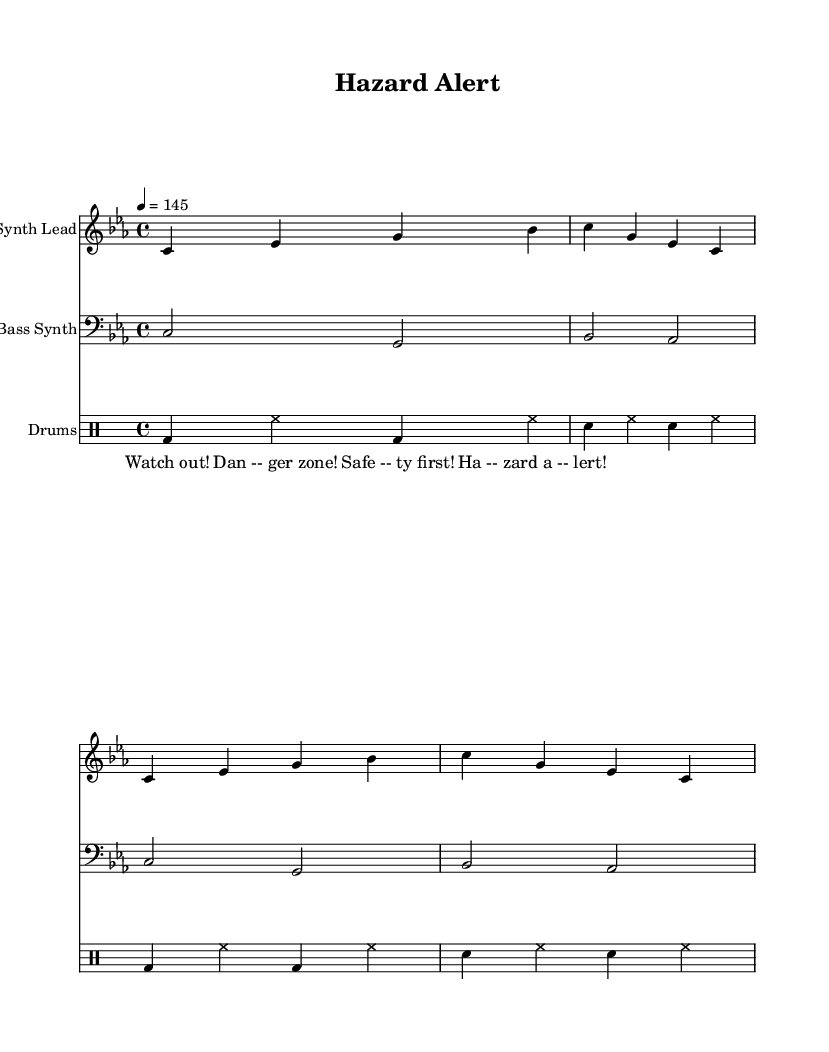What is the key signature of this music? The key signature indicates C minor, which has three flats (B flat, E flat, and A flat). This can be identified from the key signature notation found at the beginning of the staff.
Answer: C minor What is the time signature of this music? The time signature is indicated at the beginning of the score and shows 4/4, which means there are four beats in a measure and a quarter note gets one beat.
Answer: 4/4 What is the tempo marking in this music? The tempo marking is found in the score and indicates the speed of 4 beats per minute set to 145, providing a BPM (Beats Per Minute) reference for performance.
Answer: 145 How many measures are in the synth lead section? Counting the number of measures in the synth lead, there are 4 measures shown in the provided part of the score. Each group of notes is separated by vertical lines representing the measures.
Answer: 4 Which instrument performs the bass synth part? The bass synth part is labeled clearly in the score, with the staff being identified as "Bass Synth," thus indicating which instrument is playing this part.
Answer: Bass Synth What is the rhythmic pattern used in the drum section? The drum section showcases a pattern consisting of kick drums (bd), snare drums (sn), and hi-hat (hh) notes, representative of a standard electronic drum pattern focused on a driving rhythm often found in techno music.
Answer: Kick and Snare pattern 